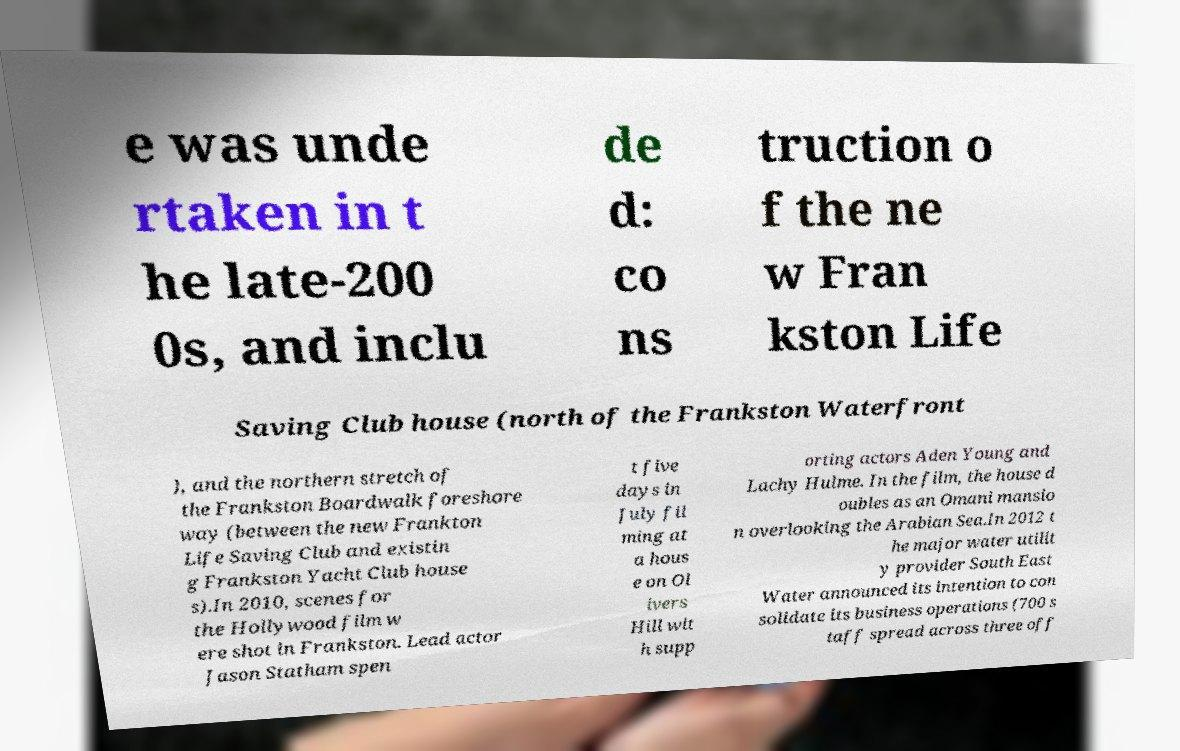What messages or text are displayed in this image? I need them in a readable, typed format. e was unde rtaken in t he late-200 0s, and inclu de d: co ns truction o f the ne w Fran kston Life Saving Club house (north of the Frankston Waterfront ), and the northern stretch of the Frankston Boardwalk foreshore way (between the new Frankton Life Saving Club and existin g Frankston Yacht Club house s).In 2010, scenes for the Hollywood film w ere shot in Frankston. Lead actor Jason Statham spen t five days in July fil ming at a hous e on Ol ivers Hill wit h supp orting actors Aden Young and Lachy Hulme. In the film, the house d oubles as an Omani mansio n overlooking the Arabian Sea.In 2012 t he major water utilit y provider South East Water announced its intention to con solidate its business operations (700 s taff spread across three off 